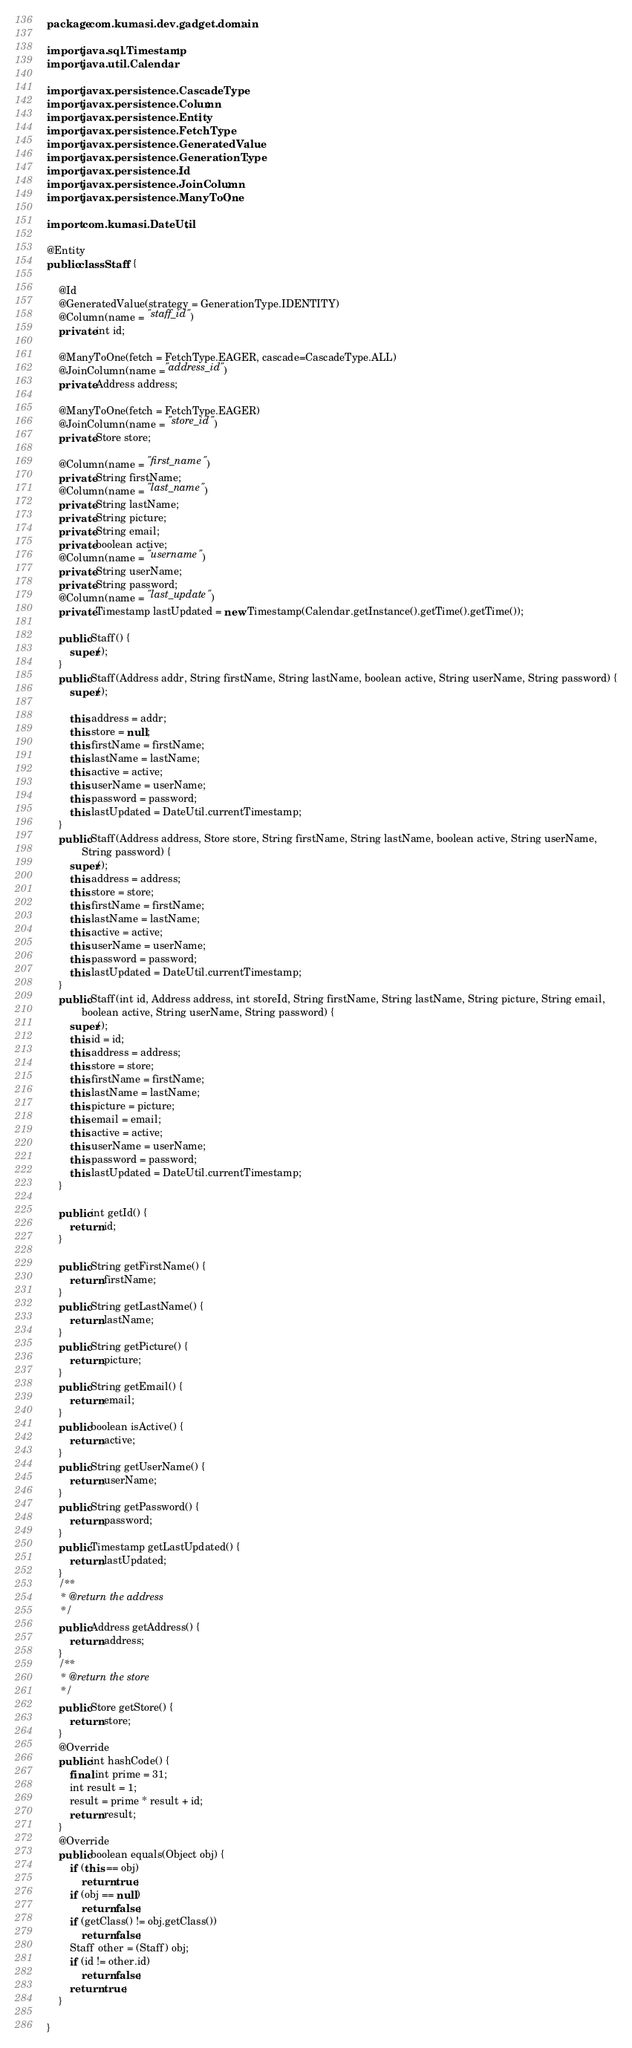<code> <loc_0><loc_0><loc_500><loc_500><_Java_>package com.kumasi.dev.gadget.domain;

import java.sql.Timestamp;
import java.util.Calendar;

import javax.persistence.CascadeType;
import javax.persistence.Column;
import javax.persistence.Entity;
import javax.persistence.FetchType;
import javax.persistence.GeneratedValue;
import javax.persistence.GenerationType;
import javax.persistence.Id;
import javax.persistence.JoinColumn;
import javax.persistence.ManyToOne;

import com.kumasi.DateUtil;

@Entity
public class Staff {

	@Id
	@GeneratedValue(strategy = GenerationType.IDENTITY)
	@Column(name = "staff_id")
	private int id;
	
	@ManyToOne(fetch = FetchType.EAGER, cascade=CascadeType.ALL)
	@JoinColumn(name ="address_id")
	private Address address;
	
	@ManyToOne(fetch = FetchType.EAGER)
    @JoinColumn(name = "store_id")
	private Store store;
	
	@Column(name = "first_name")
	private String firstName;
	@Column(name = "last_name")
	private String lastName;
	private String picture;
	private String email;
	private boolean active;
	@Column(name = "username")
	private String userName;
	private String password;
	@Column(name = "last_update")
	private Timestamp lastUpdated = new Timestamp(Calendar.getInstance().getTime().getTime());
	
	public Staff() {
		super();
	}
	public Staff(Address addr, String firstName, String lastName, boolean active, String userName, String password) {
		super();

		this.address = addr;
		this.store = null;
		this.firstName = firstName;
		this.lastName = lastName;
		this.active = active;
		this.userName = userName;
		this.password = password;
		this.lastUpdated = DateUtil.currentTimestamp;
	}
	public Staff(Address address, Store store, String firstName, String lastName, boolean active, String userName,
			String password) {
		super();
		this.address = address;
		this.store = store;
		this.firstName = firstName;
		this.lastName = lastName;
		this.active = active;
		this.userName = userName;
		this.password = password;
		this.lastUpdated = DateUtil.currentTimestamp;
	}
	public Staff(int id, Address address, int storeId, String firstName, String lastName, String picture, String email,
			boolean active, String userName, String password) {
		super();
		this.id = id;
		this.address = address;
		this.store = store;
		this.firstName = firstName;
		this.lastName = lastName;
		this.picture = picture;
		this.email = email;
		this.active = active;
		this.userName = userName;
		this.password = password;
		this.lastUpdated = DateUtil.currentTimestamp;
	}
	
	public int getId() {
		return id;
	}
	
	public String getFirstName() {
		return firstName;
	}
	public String getLastName() {
		return lastName;
	}
	public String getPicture() {
		return picture;
	}
	public String getEmail() {
		return email;
	}
	public boolean isActive() {
		return active;
	}
	public String getUserName() {
		return userName;
	}
	public String getPassword() {
		return password;
	}
	public Timestamp getLastUpdated() {
		return lastUpdated;
	}
	/**
	 * @return the address
	 */
	public Address getAddress() {
		return address;
	}
	/**
	 * @return the store
	 */
	public Store getStore() {
		return store;
	}
	@Override
	public int hashCode() {
		final int prime = 31;
		int result = 1;
		result = prime * result + id;
		return result;
	}
	@Override
	public boolean equals(Object obj) {
		if (this == obj)
			return true;
		if (obj == null)
			return false;
		if (getClass() != obj.getClass())
			return false;
		Staff other = (Staff) obj;
		if (id != other.id)
			return false;
		return true;
	}
		
}
</code> 